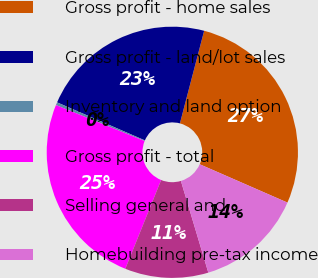Convert chart. <chart><loc_0><loc_0><loc_500><loc_500><pie_chart><fcel>Gross profit - home sales<fcel>Gross profit - land/lot sales<fcel>Inventory and land option<fcel>Gross profit - total<fcel>Selling general and<fcel>Homebuilding pre-tax income<nl><fcel>27.48%<fcel>22.57%<fcel>0.37%<fcel>25.03%<fcel>10.73%<fcel>13.82%<nl></chart> 